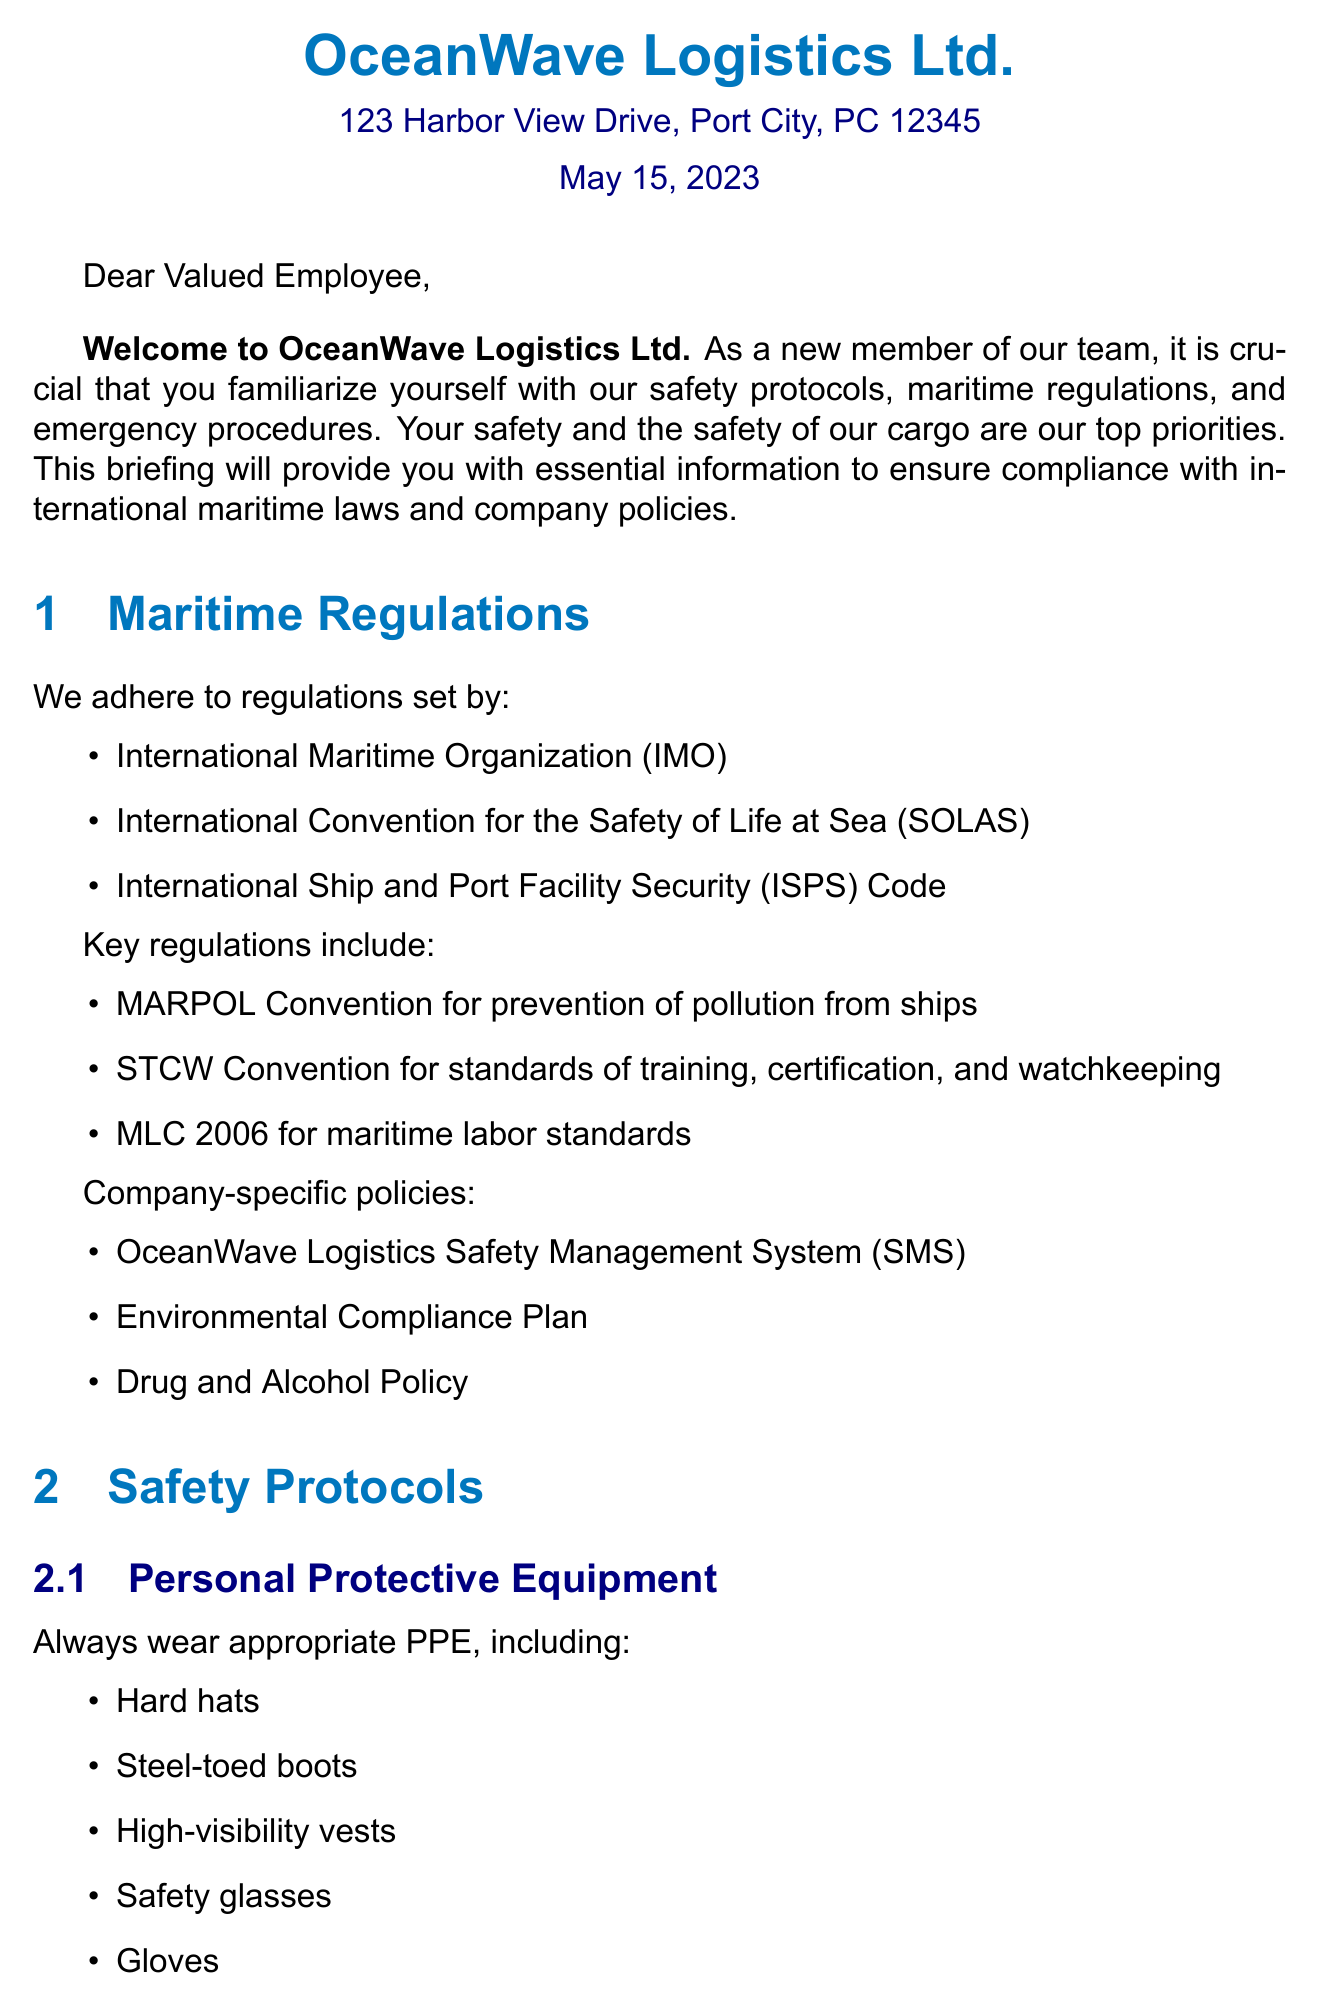What is the name of the company? The company name is provided in the letter header section.
Answer: OceanWave Logistics Ltd What is the address of the company? The address can be found in the letter header section of the document.
Answer: 123 Harbor View Drive, Port City, PC 12345 Who is the Chief Safety Officer? The document states the name and title of the person who signed the letter.
Answer: Captain Sarah Johnson What is the date of the letter? The date is clearly mentioned in the letter header.
Answer: May 15, 2023 What are the key regulations mentioned in the letter? The document lists several key maritime regulations.
Answer: MARPOL Convention, STCW Convention, MLC 2006 What should you do if there is a man overboard? This information is provided in the emergency procedures section detailing the steps.
Answer: Shout 'Man Overboard' and throw a lifebuoy What type of training is required? The letter specifies required courses in the training section.
Answer: Basic Safety Training (BST) What is the primary focus of the letter? The introduction clearly outlines the purpose of the communication.
Answer: Safety protocols and emergency procedures What should you wear as personal protective equipment? Safety protocols include a list of required personal protective equipment.
Answer: Hard hats, steel-toed boots, high-visibility vests, safety glasses, gloves 